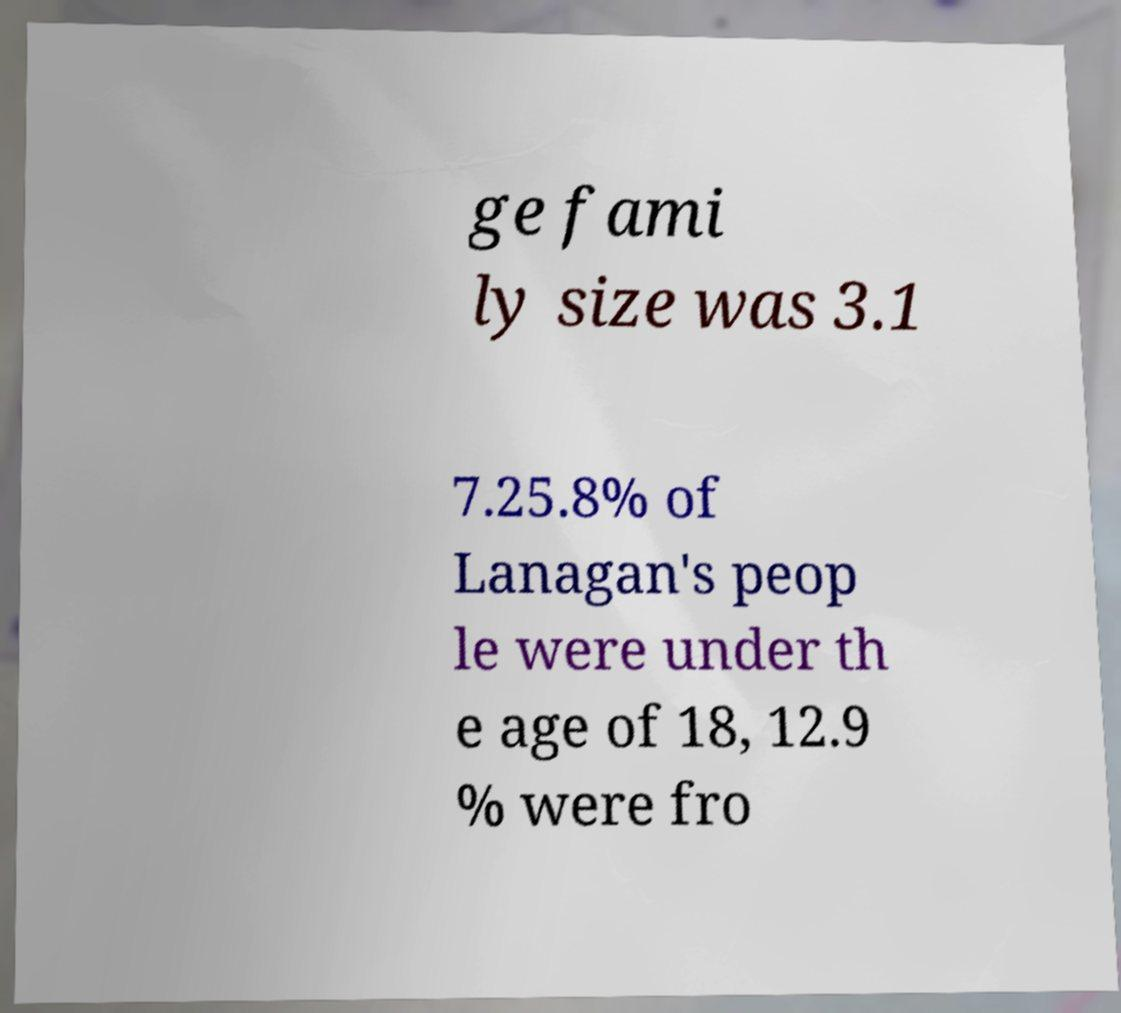For documentation purposes, I need the text within this image transcribed. Could you provide that? ge fami ly size was 3.1 7.25.8% of Lanagan's peop le were under th e age of 18, 12.9 % were fro 